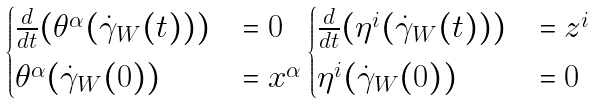<formula> <loc_0><loc_0><loc_500><loc_500>\begin{cases} \frac { d } { d t } ( \theta ^ { \alpha } ( \dot { \gamma } _ { W } ( t ) ) ) & = 0 \\ \theta ^ { \alpha } ( \dot { \gamma } _ { W } ( 0 ) ) & = x ^ { \alpha } \end{cases} \begin{cases} \frac { d } { d t } ( \eta ^ { i } ( \dot { \gamma } _ { W } ( t ) ) ) & = z ^ { i } \\ \eta ^ { i } ( \dot { \gamma } _ { W } ( 0 ) ) & = 0 \end{cases}</formula> 